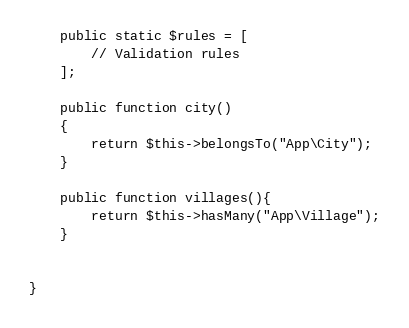<code> <loc_0><loc_0><loc_500><loc_500><_PHP_>    public static $rules = [
        // Validation rules
    ];

    public function city()
    {
        return $this->belongsTo("App\City");
    }

    public function villages(){
        return $this->hasMany("App\Village");
    }


}
</code> 